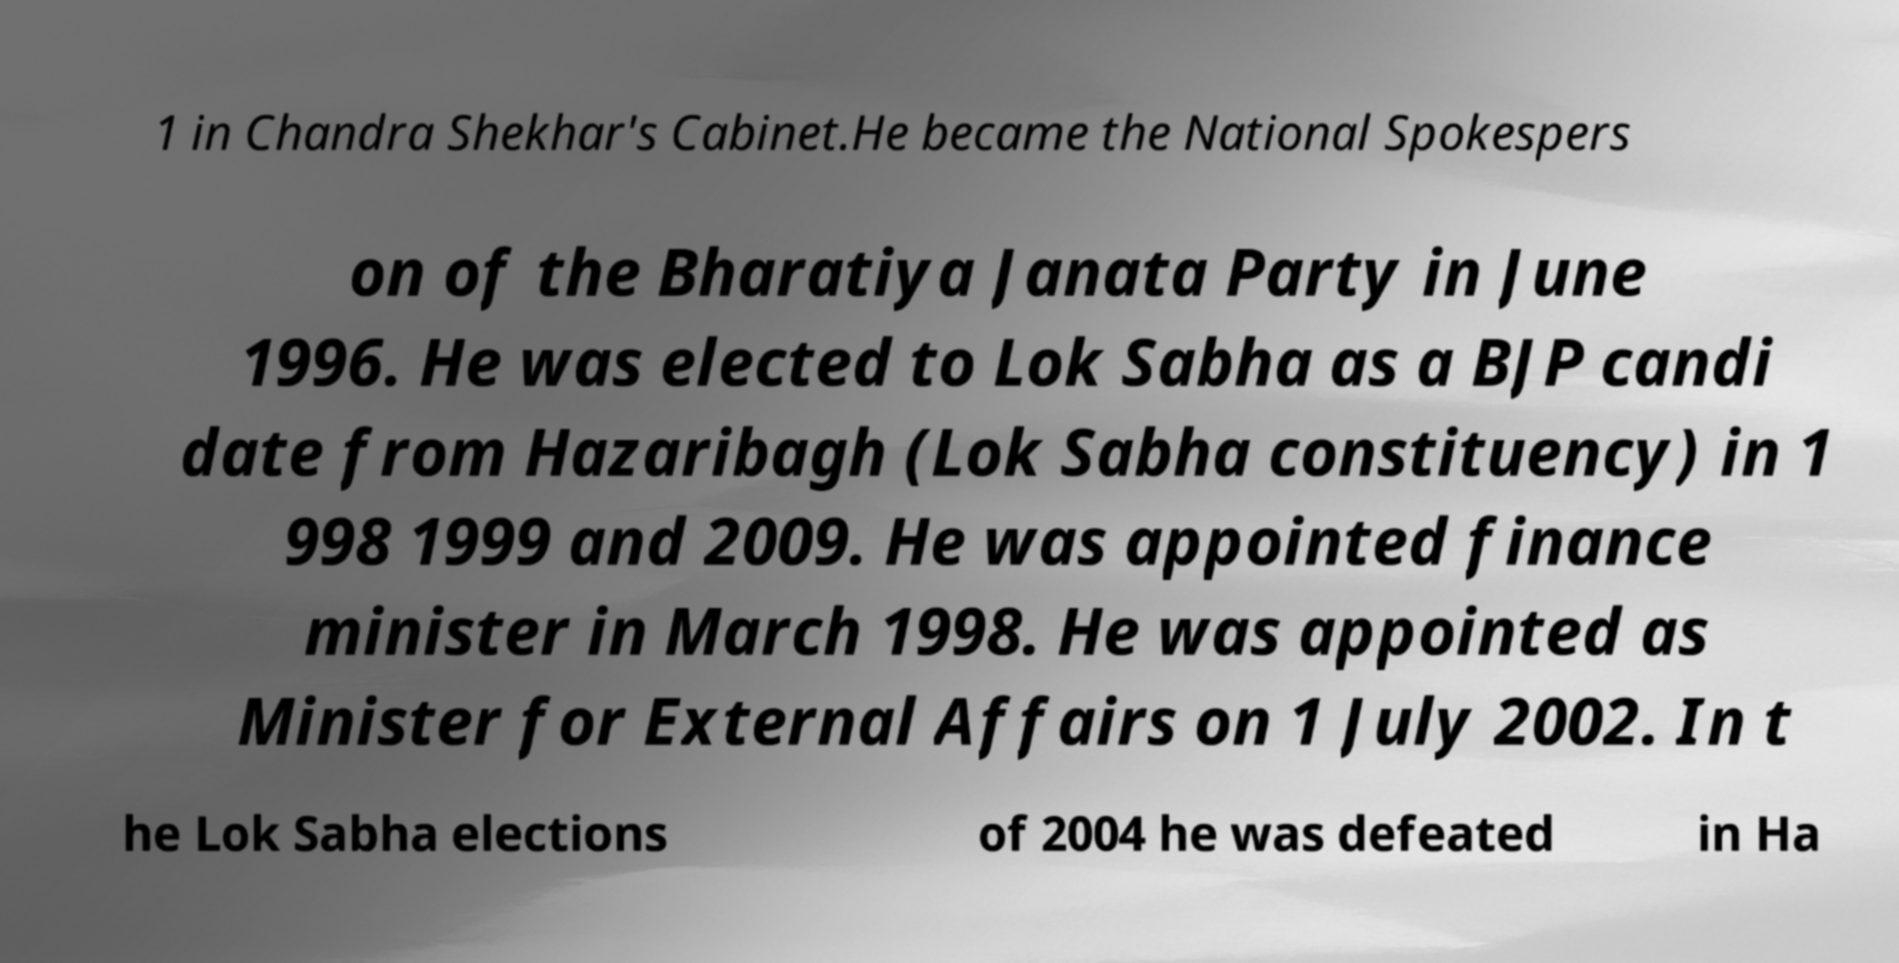Could you assist in decoding the text presented in this image and type it out clearly? 1 in Chandra Shekhar's Cabinet.He became the National Spokespers on of the Bharatiya Janata Party in June 1996. He was elected to Lok Sabha as a BJP candi date from Hazaribagh (Lok Sabha constituency) in 1 998 1999 and 2009. He was appointed finance minister in March 1998. He was appointed as Minister for External Affairs on 1 July 2002. In t he Lok Sabha elections of 2004 he was defeated in Ha 